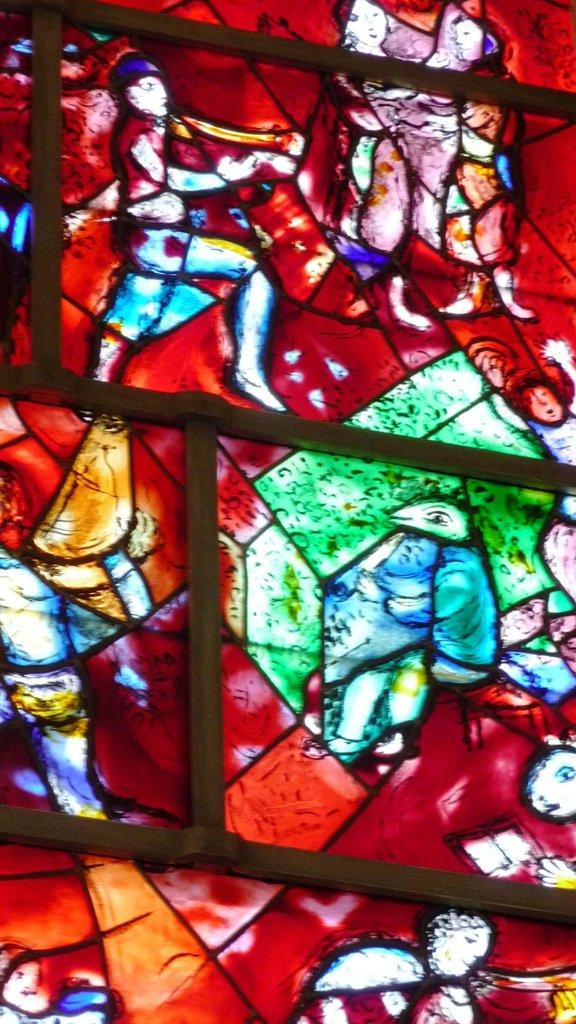What can be seen in the foreground of the image? There are objects in the foreground of the image. What is located in the background of the image? There is stained glass in the background of the image. What is depicted on the stained glass? There are pictures of persons and objects on the stained glass. What type of songs can be heard playing in the background of the image? There is no audio or sound present in the image, so it is not possible to determine what songs might be heard. 